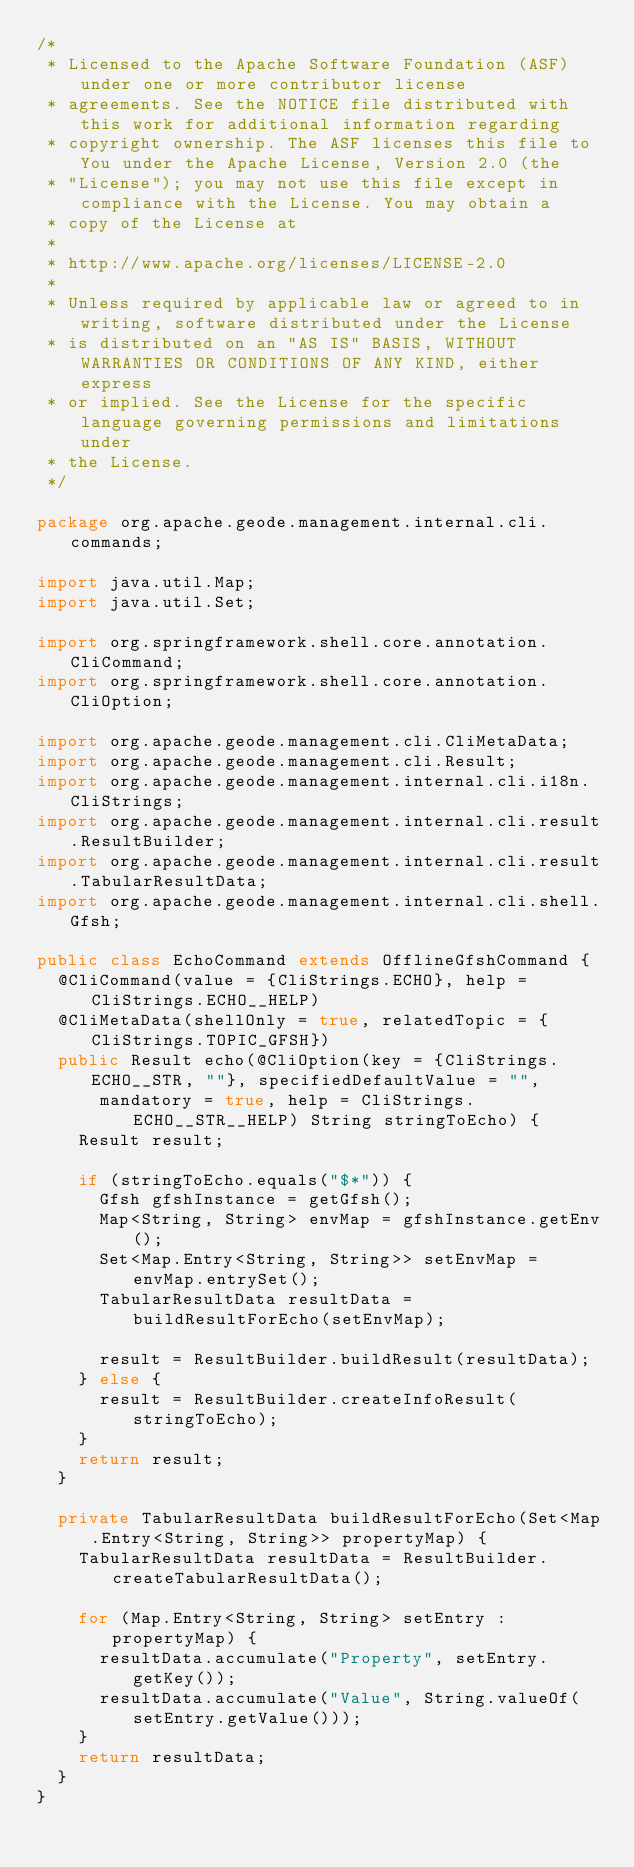Convert code to text. <code><loc_0><loc_0><loc_500><loc_500><_Java_>/*
 * Licensed to the Apache Software Foundation (ASF) under one or more contributor license
 * agreements. See the NOTICE file distributed with this work for additional information regarding
 * copyright ownership. The ASF licenses this file to You under the Apache License, Version 2.0 (the
 * "License"); you may not use this file except in compliance with the License. You may obtain a
 * copy of the License at
 *
 * http://www.apache.org/licenses/LICENSE-2.0
 *
 * Unless required by applicable law or agreed to in writing, software distributed under the License
 * is distributed on an "AS IS" BASIS, WITHOUT WARRANTIES OR CONDITIONS OF ANY KIND, either express
 * or implied. See the License for the specific language governing permissions and limitations under
 * the License.
 */

package org.apache.geode.management.internal.cli.commands;

import java.util.Map;
import java.util.Set;

import org.springframework.shell.core.annotation.CliCommand;
import org.springframework.shell.core.annotation.CliOption;

import org.apache.geode.management.cli.CliMetaData;
import org.apache.geode.management.cli.Result;
import org.apache.geode.management.internal.cli.i18n.CliStrings;
import org.apache.geode.management.internal.cli.result.ResultBuilder;
import org.apache.geode.management.internal.cli.result.TabularResultData;
import org.apache.geode.management.internal.cli.shell.Gfsh;

public class EchoCommand extends OfflineGfshCommand {
  @CliCommand(value = {CliStrings.ECHO}, help = CliStrings.ECHO__HELP)
  @CliMetaData(shellOnly = true, relatedTopic = {CliStrings.TOPIC_GFSH})
  public Result echo(@CliOption(key = {CliStrings.ECHO__STR, ""}, specifiedDefaultValue = "",
      mandatory = true, help = CliStrings.ECHO__STR__HELP) String stringToEcho) {
    Result result;

    if (stringToEcho.equals("$*")) {
      Gfsh gfshInstance = getGfsh();
      Map<String, String> envMap = gfshInstance.getEnv();
      Set<Map.Entry<String, String>> setEnvMap = envMap.entrySet();
      TabularResultData resultData = buildResultForEcho(setEnvMap);

      result = ResultBuilder.buildResult(resultData);
    } else {
      result = ResultBuilder.createInfoResult(stringToEcho);
    }
    return result;
  }

  private TabularResultData buildResultForEcho(Set<Map.Entry<String, String>> propertyMap) {
    TabularResultData resultData = ResultBuilder.createTabularResultData();

    for (Map.Entry<String, String> setEntry : propertyMap) {
      resultData.accumulate("Property", setEntry.getKey());
      resultData.accumulate("Value", String.valueOf(setEntry.getValue()));
    }
    return resultData;
  }
}
</code> 